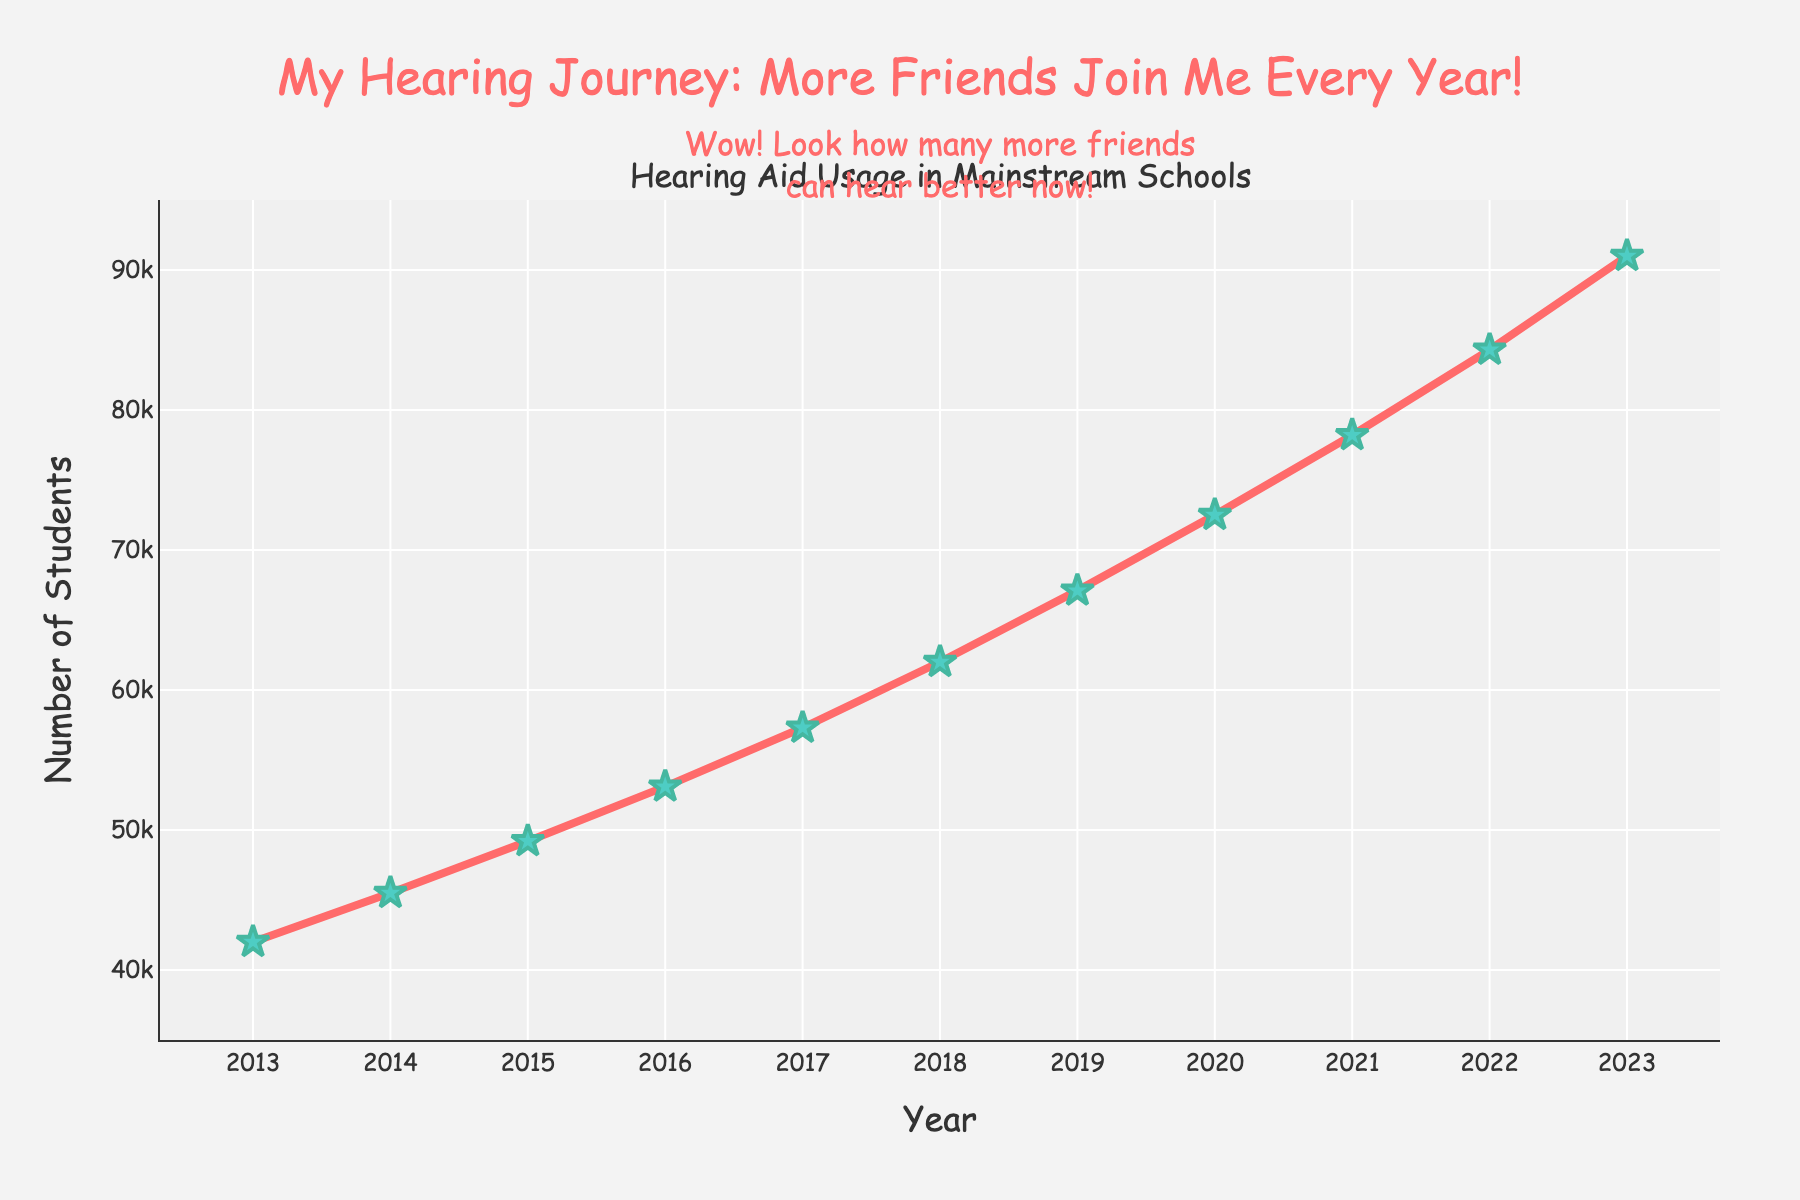How many more students used hearing aids in 2023 compared to 2013? Look at the data points for 2023 and 2013: 91000 in 2023 and 42000 in 2013. Subtract the 2013 value from the 2023 value: 91000 - 42000.
Answer: 49000 Did the number of students using hearing aids increase every year? Check the data points for each successive year from 2013 to 2023. Each year shows an increase from the previous year.
Answer: Yes Which year had the highest number of students using hearing aids? Look at the data points and the highest point on the line chart. The highest value is in 2023 with 91000 students.
Answer: 2023 How much did the number of students using hearing aids increase from 2018 to 2019? Refer to the values for 2018 and 2019: 62000 in 2018 and 67100 in 2019. Subtract the 2018 value from the 2019 value: 67100 - 62000.
Answer: 5100 What is the average number of students using hearing aids over the past decade? Sum all the data points from 2013 to 2023 and then divide by the number of years (11): (42000 + 45500 + 49200 + 53100 + 57300 + 62000 + 67100 + 72500 + 78200 + 84300 + 91000) / 11.
Answer: 63636.36 Was the increase in the number of students using hearing aids larger between 2016-2017 or 2021-2022? Calculate the increase for each period: 2016-2017 is 57300 - 53100 = 4200, and 2021-2022 is 84300 - 78200 = 6100. Compare the two values.
Answer: 2021-2022 What color are the markers on the line plot? Observe the color of the markers on the chart. They are identified by their color attribute.
Answer: Green How many students used hearing aids in the middle year of the dataset (i.e., 2018)? Identify the data point corresponding to the year 2018, which is the middle year in a range from 2013 to 2023.
Answer: 62000 